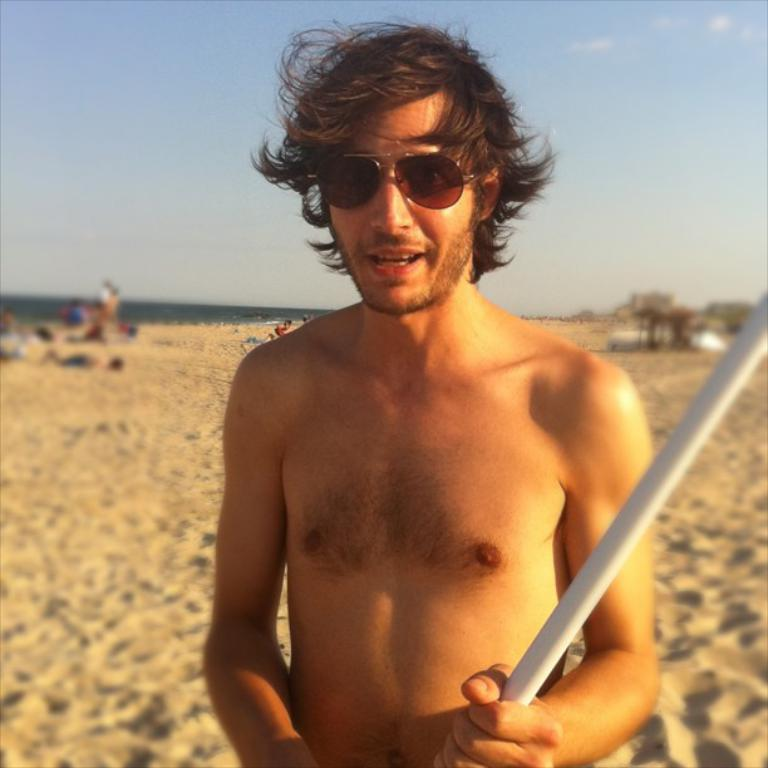What is the person in the image holding? The person is holding a rod. What protective gear is the person wearing? The person is wearing goggles. Can you describe the background of the image? The background is blurred, but there are people visible, sand, and the sky. What shape is the sister's guitar in the image? There is no sister or guitar present in the image. 